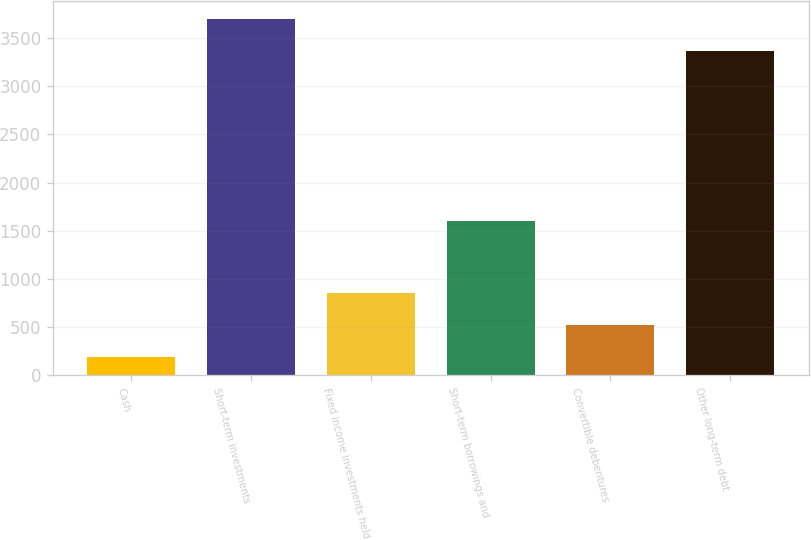Convert chart to OTSL. <chart><loc_0><loc_0><loc_500><loc_500><bar_chart><fcel>Cash<fcel>Short-term investments<fcel>Fixed income investments held<fcel>Short-term borrowings and<fcel>Convertible debentures<fcel>Other long-term debt<nl><fcel>189<fcel>3703.4<fcel>851.8<fcel>1598<fcel>520.4<fcel>3372<nl></chart> 